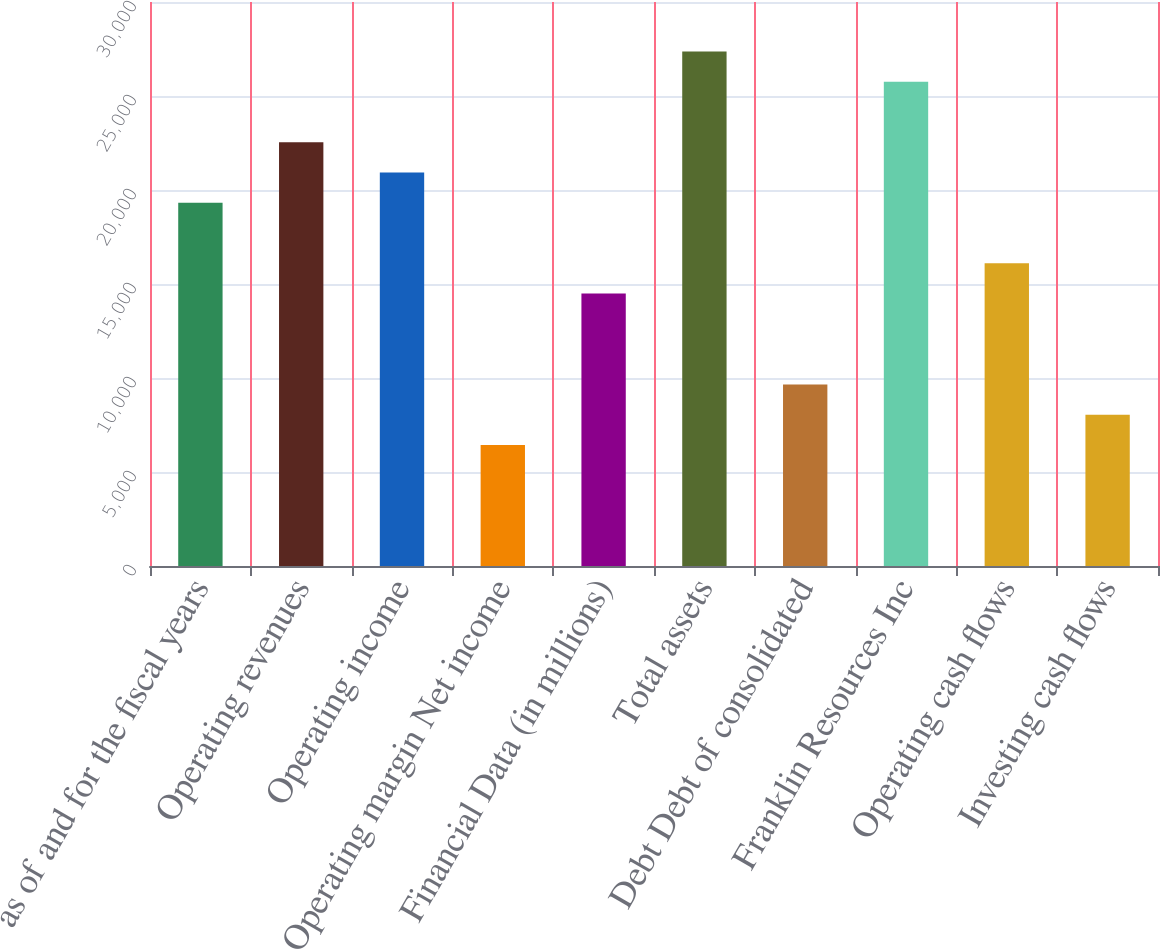Convert chart to OTSL. <chart><loc_0><loc_0><loc_500><loc_500><bar_chart><fcel>as of and for the fiscal years<fcel>Operating revenues<fcel>Operating income<fcel>Operating margin Net income<fcel>Financial Data (in millions)<fcel>Total assets<fcel>Debt Debt of consolidated<fcel>Franklin Resources Inc<fcel>Operating cash flows<fcel>Investing cash flows<nl><fcel>19318.4<fcel>22538.1<fcel>20928.2<fcel>6439.96<fcel>14489<fcel>27367.5<fcel>9659.58<fcel>25757.7<fcel>16098.8<fcel>8049.77<nl></chart> 